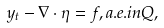<formula> <loc_0><loc_0><loc_500><loc_500>y _ { t } - \nabla \cdot \eta = f , a . e . i n Q ,</formula> 